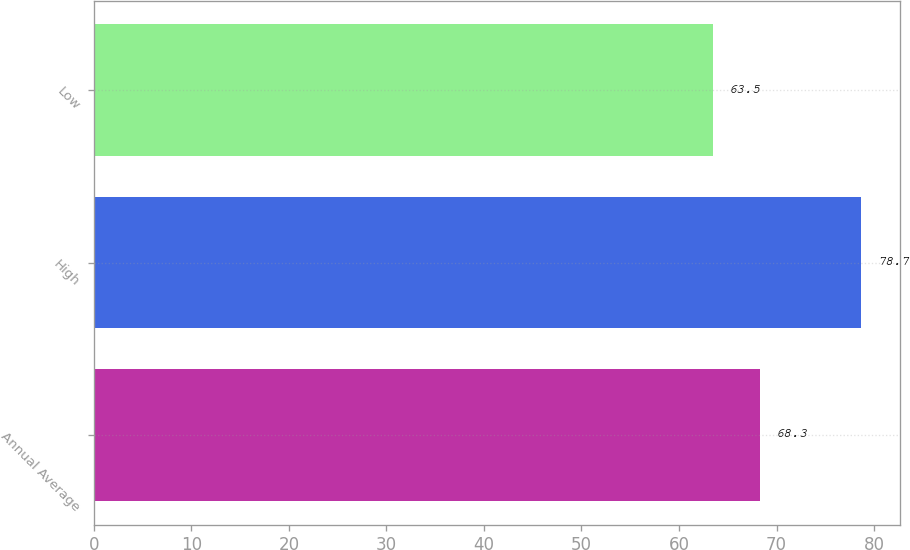Convert chart to OTSL. <chart><loc_0><loc_0><loc_500><loc_500><bar_chart><fcel>Annual Average<fcel>High<fcel>Low<nl><fcel>68.3<fcel>78.7<fcel>63.5<nl></chart> 